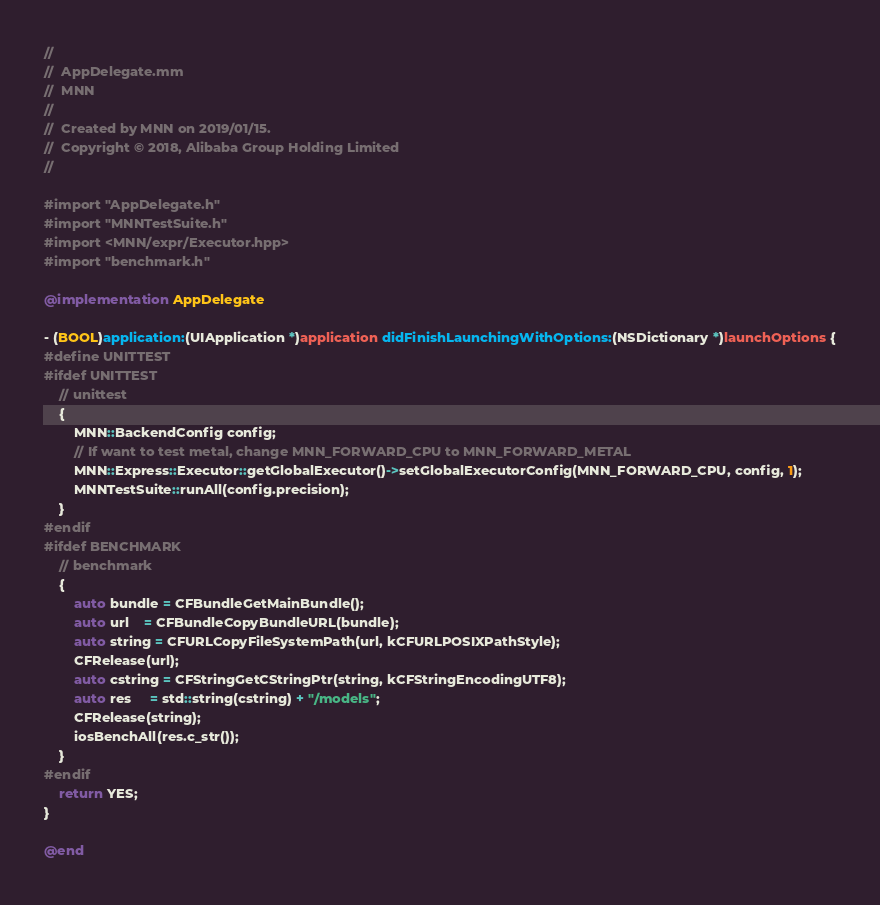<code> <loc_0><loc_0><loc_500><loc_500><_ObjectiveC_>//
//  AppDelegate.mm
//  MNN
//
//  Created by MNN on 2019/01/15.
//  Copyright © 2018, Alibaba Group Holding Limited
//

#import "AppDelegate.h"
#import "MNNTestSuite.h"
#import <MNN/expr/Executor.hpp>
#import "benchmark.h"

@implementation AppDelegate

- (BOOL)application:(UIApplication *)application didFinishLaunchingWithOptions:(NSDictionary *)launchOptions {
#define UNITTEST
#ifdef UNITTEST
    // unittest
    {
        MNN::BackendConfig config;
        // If want to test metal, change MNN_FORWARD_CPU to MNN_FORWARD_METAL
        MNN::Express::Executor::getGlobalExecutor()->setGlobalExecutorConfig(MNN_FORWARD_CPU, config, 1);
        MNNTestSuite::runAll(config.precision);
    }
#endif
#ifdef BENCHMARK
    // benchmark
    {
        auto bundle = CFBundleGetMainBundle();
        auto url    = CFBundleCopyBundleURL(bundle);
        auto string = CFURLCopyFileSystemPath(url, kCFURLPOSIXPathStyle);
        CFRelease(url);
        auto cstring = CFStringGetCStringPtr(string, kCFStringEncodingUTF8);
        auto res     = std::string(cstring) + "/models";
        CFRelease(string);
        iosBenchAll(res.c_str());
    }
#endif
    return YES;
}

@end
</code> 